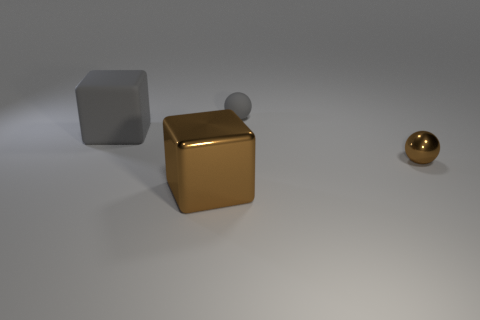Is there a brown ball that has the same size as the metal block?
Your response must be concise. No. What number of gray things are either big matte cubes or tiny rubber balls?
Your answer should be very brief. 2. What number of metal things are the same color as the tiny matte sphere?
Offer a terse response. 0. Are there any other things that have the same shape as the tiny brown metal object?
Provide a succinct answer. Yes. What number of cubes are either large shiny things or big matte objects?
Make the answer very short. 2. What is the color of the small object behind the large gray thing?
Your response must be concise. Gray. There is a object that is the same size as the brown shiny ball; what is its shape?
Your answer should be compact. Sphere. How many brown spheres are behind the gray cube?
Keep it short and to the point. 0. How many objects are either gray spheres or green shiny cylinders?
Your answer should be very brief. 1. There is a object that is in front of the big rubber cube and behind the big brown object; what shape is it?
Offer a terse response. Sphere. 